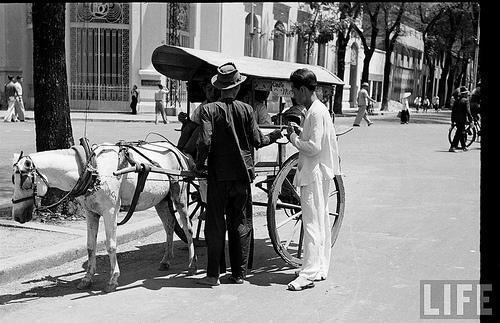How many wheels are there?
Give a very brief answer. 2. 